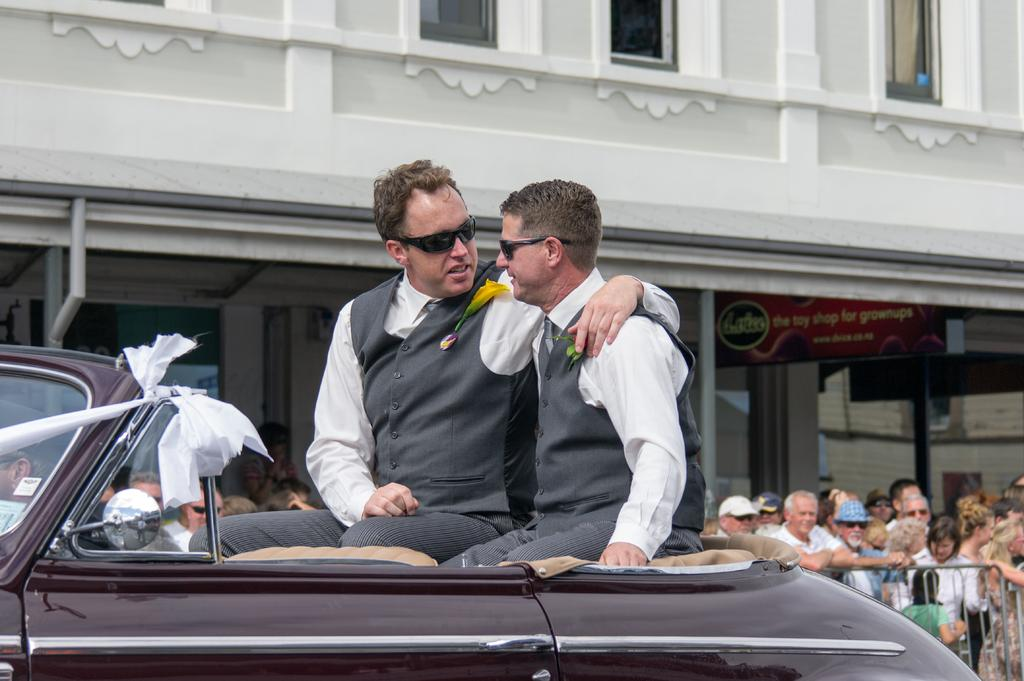What are the two people in the image doing? The two people are sitting on a car. What can be seen in the background of the image? There is a group of people standing and a building visible in the background. What type of thread is being used to hold the potato in the image? There is no thread or potato present in the image. 